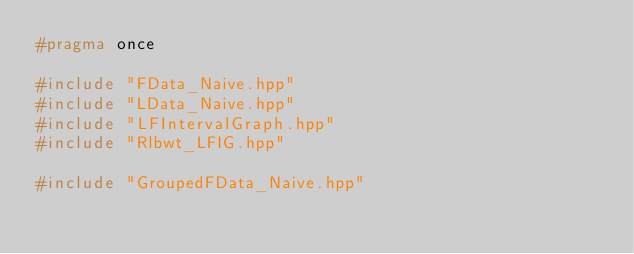<code> <loc_0><loc_0><loc_500><loc_500><_C++_>#pragma once

#include "FData_Naive.hpp"
#include "LData_Naive.hpp"
#include "LFIntervalGraph.hpp"
#include "Rlbwt_LFIG.hpp"

#include "GroupedFData_Naive.hpp"</code> 